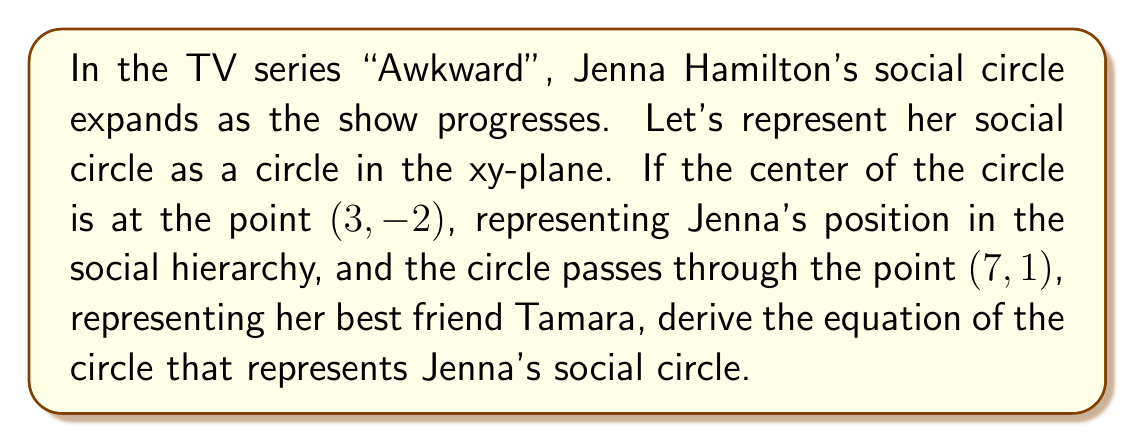Can you solve this math problem? Let's approach this step-by-step:

1) The general equation of a circle is:
   $$(x - h)^2 + (y - k)^2 = r^2$$
   where (h, k) is the center and r is the radius.

2) We're given that the center is at (3, -2), so h = 3 and k = -2.

3) We need to find r, the radius. We can do this by calculating the distance between the center (3, -2) and the point (7, 1) that lies on the circle.

4) To find the distance, we use the distance formula:
   $$r = \sqrt{(x_2 - x_1)^2 + (y_2 - y_1)^2}$$
   where (x₁, y₁) is the center and (x₂, y₂) is the point on the circle.

5) Plugging in our values:
   $$r = \sqrt{(7 - 3)^2 + (1 - (-2))^2} = \sqrt{4^2 + 3^2} = \sqrt{16 + 9} = \sqrt{25} = 5$$

6) Now that we have the center (3, -2) and the radius 5, we can write the equation of the circle:
   $$(x - 3)^2 + (y - (-2))^2 = 5^2$$

7) Simplifying:
   $$(x - 3)^2 + (y + 2)^2 = 25$$

This is the equation of the circle representing Jenna's social circle.

[asy]
import geometry;

size(200);
pair center = (3,-2);
real radius = 5;

draw(Circle(center, radius));
dot(center);
dot((7,1));

label("(3, -2)", center, SW);
label("(7, 1)", (7,1), NE);

xaxis(-2,8,Arrow);
yaxis(-7,3,Arrow);
[/asy]
Answer: $$(x - 3)^2 + (y + 2)^2 = 25$$ 